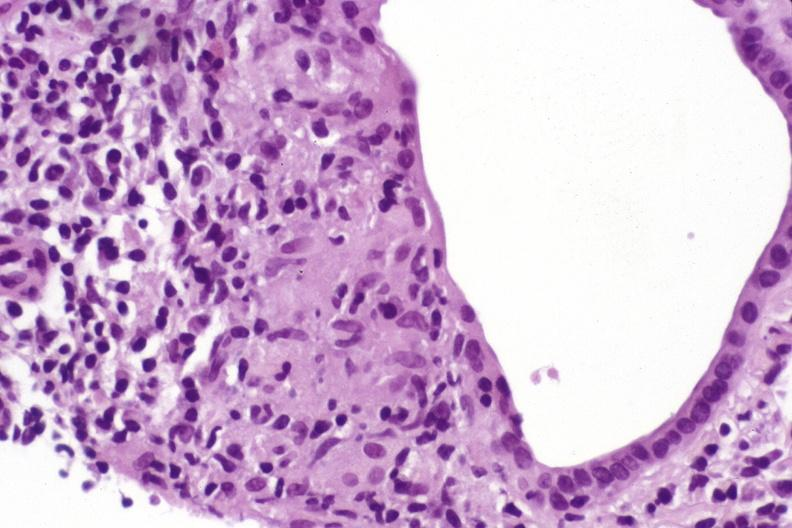what does this image show?
Answer the question using a single word or phrase. Primary biliary cirrhosis 